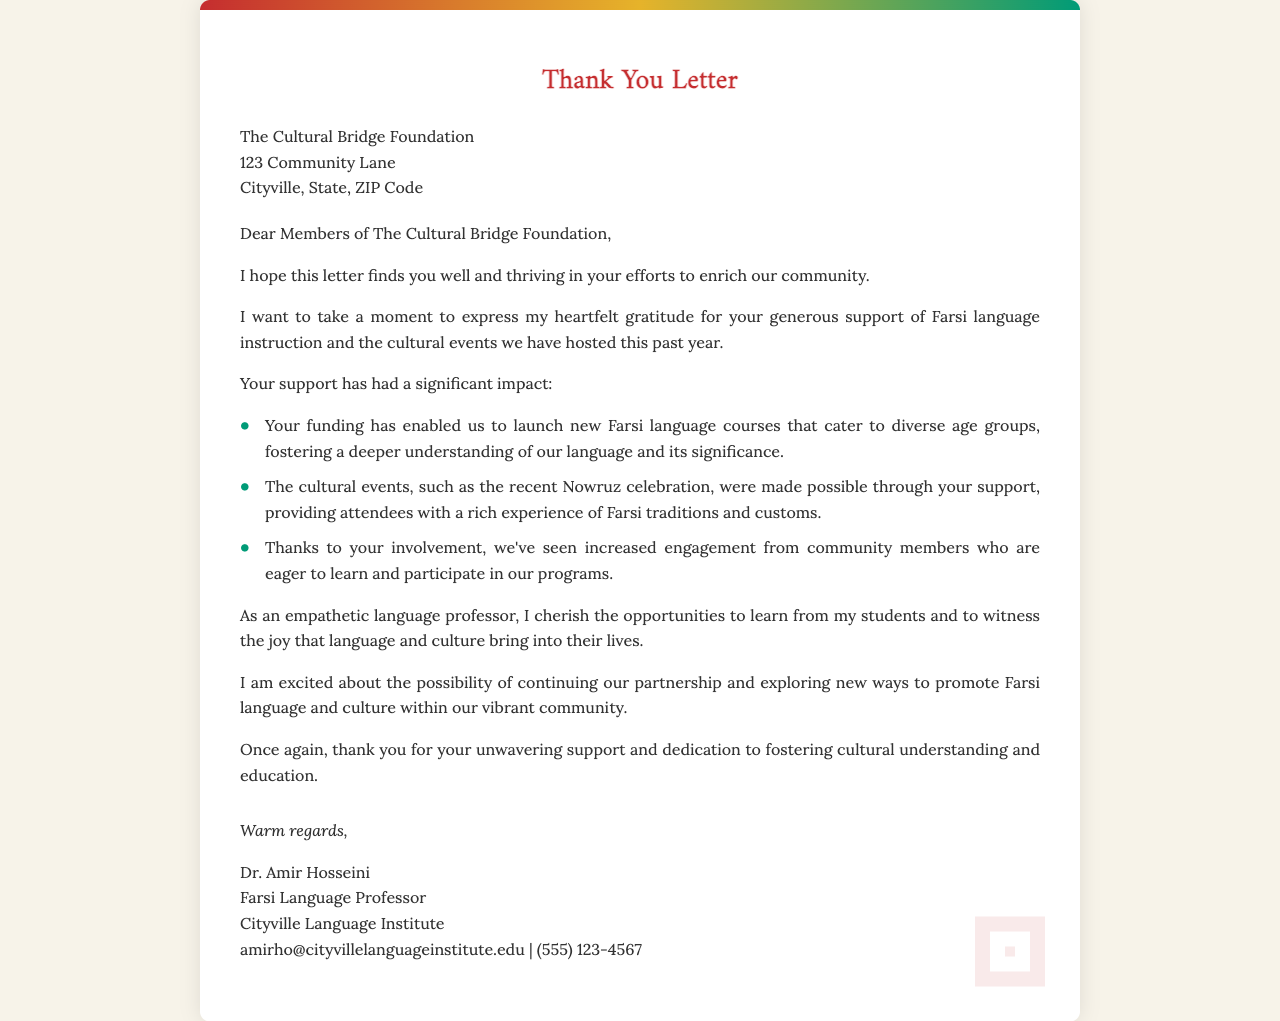What is the name of the recipient organization? The recipient organization is specifically mentioned at the beginning of the letter.
Answer: The Cultural Bridge Foundation Who is the sender of the letter? The letter clearly states the sender's name at the end.
Answer: Dr. Amir Hosseini What type of support is being thanked for in the letter? The specific type of support mentioned in the letter relates to language instruction and cultural events.
Answer: Farsi language instruction and cultural events What significant cultural event is mentioned in the letter? The letter includes a reference to an important cultural event celebrated recently.
Answer: Nowruz celebration What role does Dr. Amir Hosseini hold? The document provides the sender's professional title along with their name.
Answer: Farsi Language Professor What has been launched due to the funding mentioned? The letter highlights the outcomes of the funding received, particularly in education.
Answer: New Farsi language courses How has the funding impacted community engagement? The letter notes the influence of support on community involvement with the programs offered.
Answer: Increased engagement What is the ultimate goal expressed by Dr. Amir Hosseini? The key objective conveyed in the document relates to the future aspirations of the sender.
Answer: Continue partnership and promote Farsi language and culture 